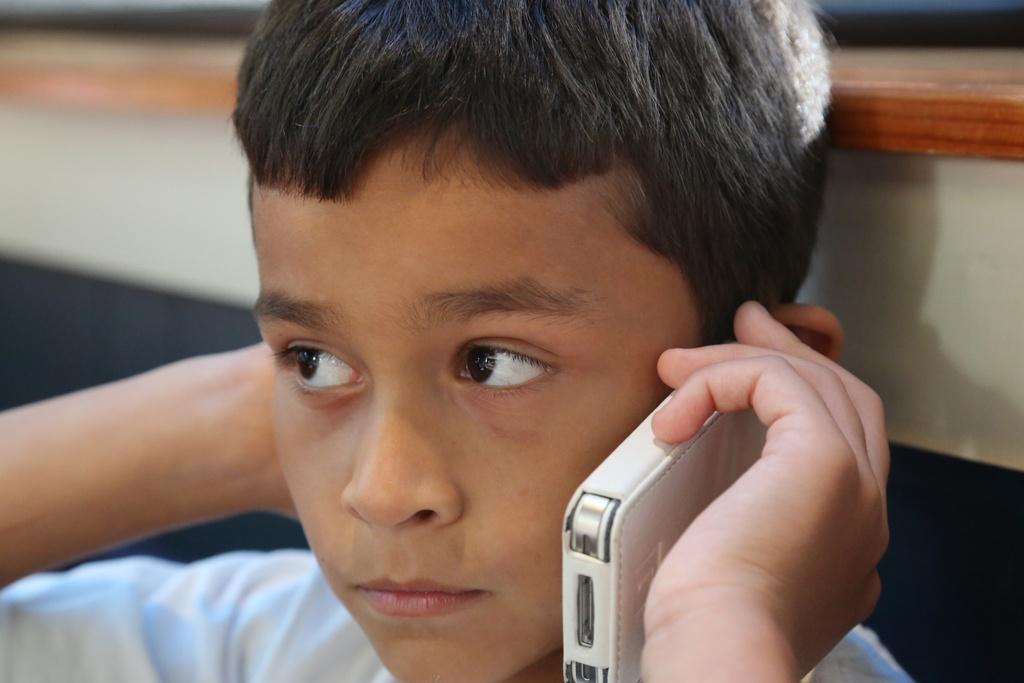Could you give a brief overview of what you see in this image? In this image there is a person who is answering a phone by holding it on his left hand and at the backside of the image there is brown and white color wall 